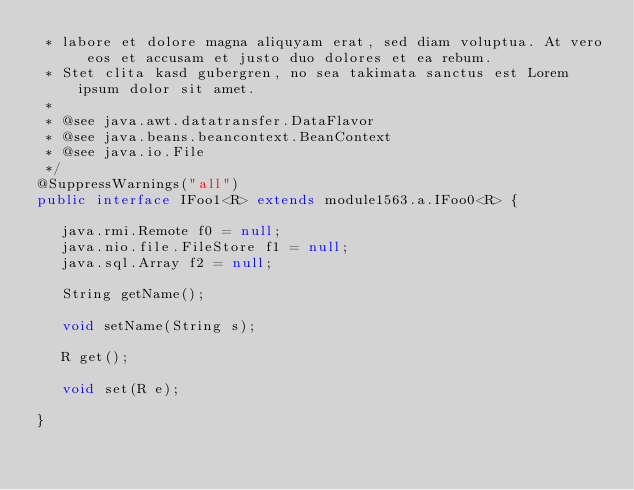<code> <loc_0><loc_0><loc_500><loc_500><_Java_> * labore et dolore magna aliquyam erat, sed diam voluptua. At vero eos et accusam et justo duo dolores et ea rebum. 
 * Stet clita kasd gubergren, no sea takimata sanctus est Lorem ipsum dolor sit amet. 
 *
 * @see java.awt.datatransfer.DataFlavor
 * @see java.beans.beancontext.BeanContext
 * @see java.io.File
 */
@SuppressWarnings("all")
public interface IFoo1<R> extends module1563.a.IFoo0<R> {

	 java.rmi.Remote f0 = null;
	 java.nio.file.FileStore f1 = null;
	 java.sql.Array f2 = null;

	 String getName();

	 void setName(String s);

	 R get();

	 void set(R e);

}
</code> 